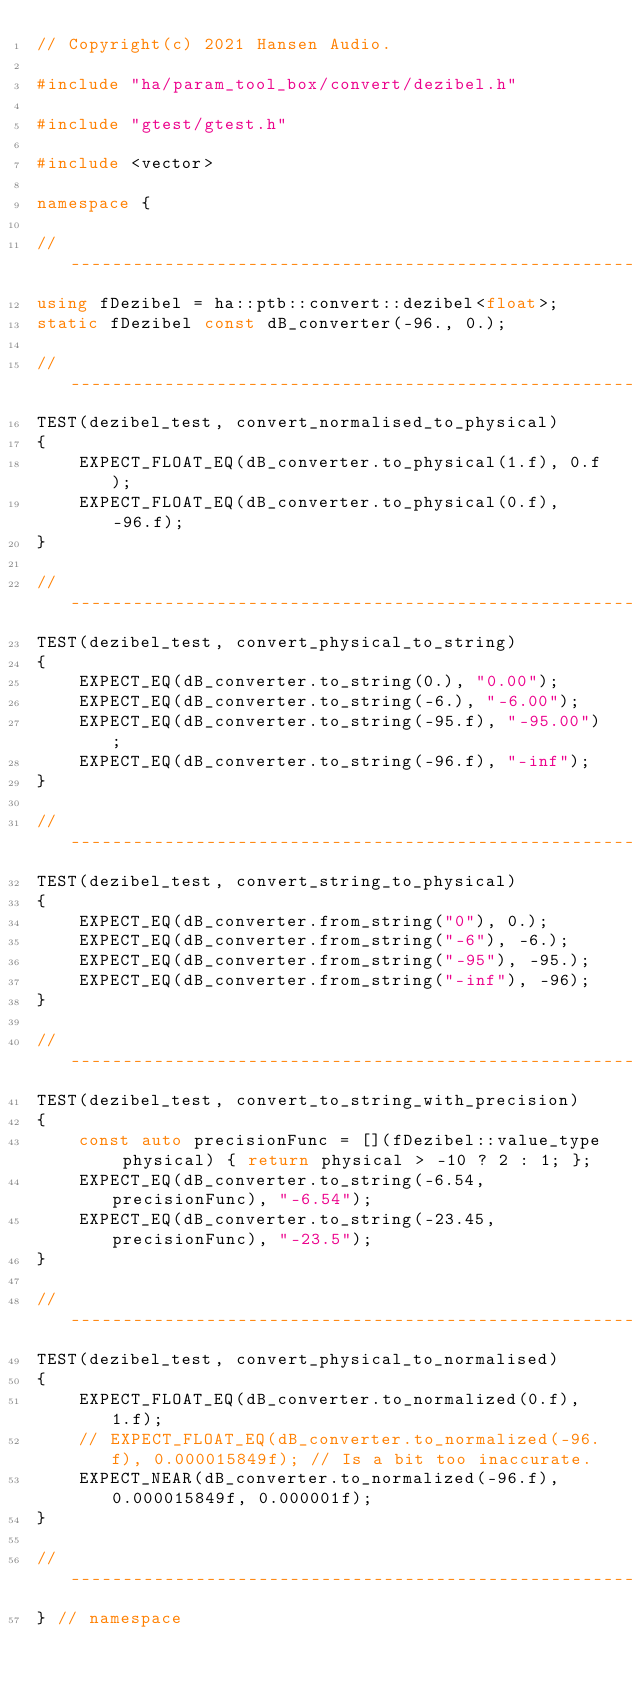Convert code to text. <code><loc_0><loc_0><loc_500><loc_500><_C++_>// Copyright(c) 2021 Hansen Audio.

#include "ha/param_tool_box/convert/dezibel.h"

#include "gtest/gtest.h"

#include <vector>

namespace {

//-----------------------------------------------------------------------------
using fDezibel = ha::ptb::convert::dezibel<float>;
static fDezibel const dB_converter(-96., 0.);

//-----------------------------------------------------------------------------
TEST(dezibel_test, convert_normalised_to_physical)
{
    EXPECT_FLOAT_EQ(dB_converter.to_physical(1.f), 0.f);
    EXPECT_FLOAT_EQ(dB_converter.to_physical(0.f), -96.f);
}

//-----------------------------------------------------------------------------
TEST(dezibel_test, convert_physical_to_string)
{
    EXPECT_EQ(dB_converter.to_string(0.), "0.00");
    EXPECT_EQ(dB_converter.to_string(-6.), "-6.00");
    EXPECT_EQ(dB_converter.to_string(-95.f), "-95.00");
    EXPECT_EQ(dB_converter.to_string(-96.f), "-inf");
}

//-----------------------------------------------------------------------------
TEST(dezibel_test, convert_string_to_physical)
{
    EXPECT_EQ(dB_converter.from_string("0"), 0.);
    EXPECT_EQ(dB_converter.from_string("-6"), -6.);
    EXPECT_EQ(dB_converter.from_string("-95"), -95.);
    EXPECT_EQ(dB_converter.from_string("-inf"), -96);
}

//-----------------------------------------------------------------------------
TEST(dezibel_test, convert_to_string_with_precision)
{
    const auto precisionFunc = [](fDezibel::value_type physical) { return physical > -10 ? 2 : 1; };
    EXPECT_EQ(dB_converter.to_string(-6.54, precisionFunc), "-6.54");
    EXPECT_EQ(dB_converter.to_string(-23.45, precisionFunc), "-23.5");
}

//-----------------------------------------------------------------------------
TEST(dezibel_test, convert_physical_to_normalised)
{
    EXPECT_FLOAT_EQ(dB_converter.to_normalized(0.f), 1.f);
    // EXPECT_FLOAT_EQ(dB_converter.to_normalized(-96.f), 0.000015849f); // Is a bit too inaccurate.
    EXPECT_NEAR(dB_converter.to_normalized(-96.f), 0.000015849f, 0.000001f);
}

//-----------------------------------------------------------------------------
} // namespace
</code> 